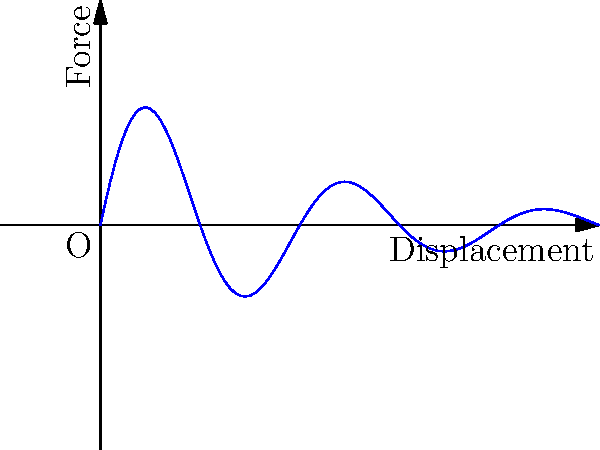In the context of Belizean engineering practices influenced by Creole culture, consider a spring-damper system that exhibits oscillatory behavior. The force-displacement curve for this system is shown above. What characteristic of the system does the decreasing amplitude of the curve represent? To understand this force-displacement curve in the context of Belizean engineering, let's break it down step-by-step:

1. The curve shows a sinusoidal pattern, which is characteristic of an oscillating system. This could represent the rhythmic movement in Belizean Creole dances or the ebb and flow of the Caribbean tides.

2. The amplitude of the oscillations decreases over time (as we move from left to right on the graph). This is similar to how the intensity of Belizean drum beats might fade in traditional music.

3. In engineering terms, this decreasing amplitude is caused by damping in the system. Damping dissipates energy over time, much like how the energy of ocean waves dissipates as they reach the Belizean shore.

4. The damping is likely viscous damping, which is proportional to velocity. This could be likened to the resistance one feels when moving through the humid Belizean air.

5. The envelope of the curve follows an exponential decay, represented mathematically as $e^{-\zeta\omega_n t}$, where $\zeta$ is the damping ratio and $\omega_n$ is the natural frequency of the system.

6. This type of response is typical of an underdamped system, where $0 < \zeta < 1$. The system oscillates but eventually comes to rest, much like how a Belizean hammock might swing after being disturbed.

Therefore, the decreasing amplitude represents the damping in the system, which causes the oscillations to gradually die out over time.
Answer: Damping in the system 